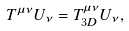<formula> <loc_0><loc_0><loc_500><loc_500>T ^ { \mu \nu } U _ { \nu } = T _ { 3 D } ^ { \mu \nu } U _ { \nu } ,</formula> 